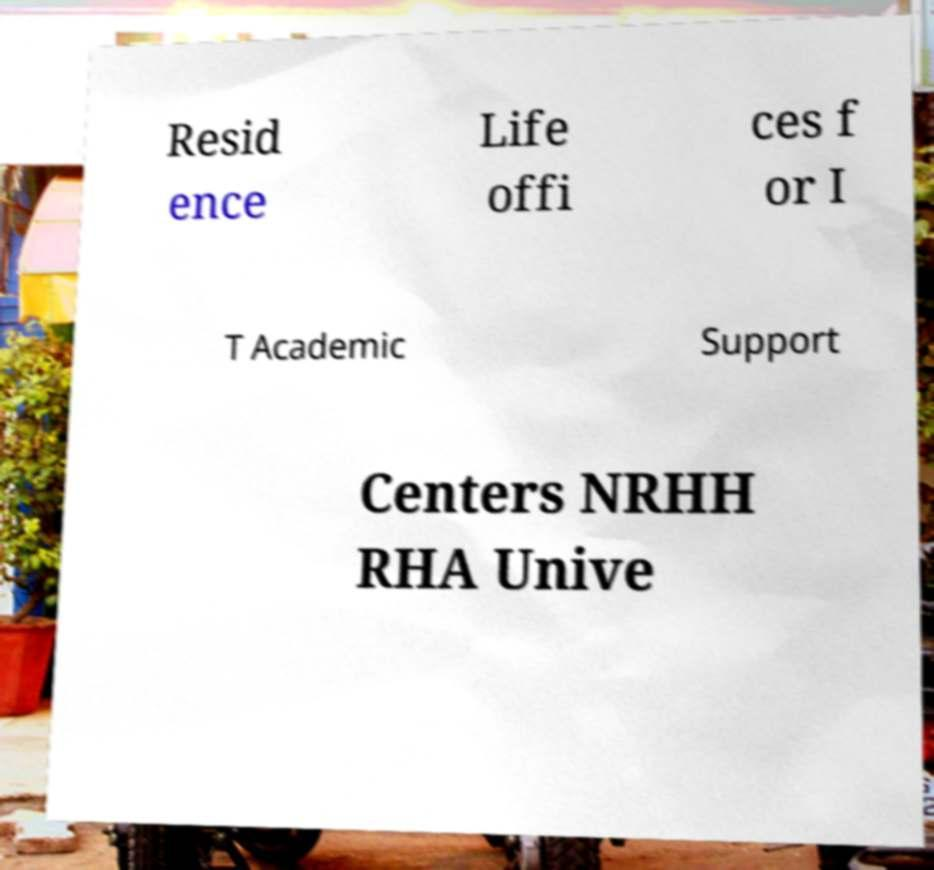Can you accurately transcribe the text from the provided image for me? Resid ence Life offi ces f or I T Academic Support Centers NRHH RHA Unive 